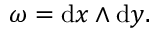<formula> <loc_0><loc_0><loc_500><loc_500>\omega = d x \wedge d y .</formula> 